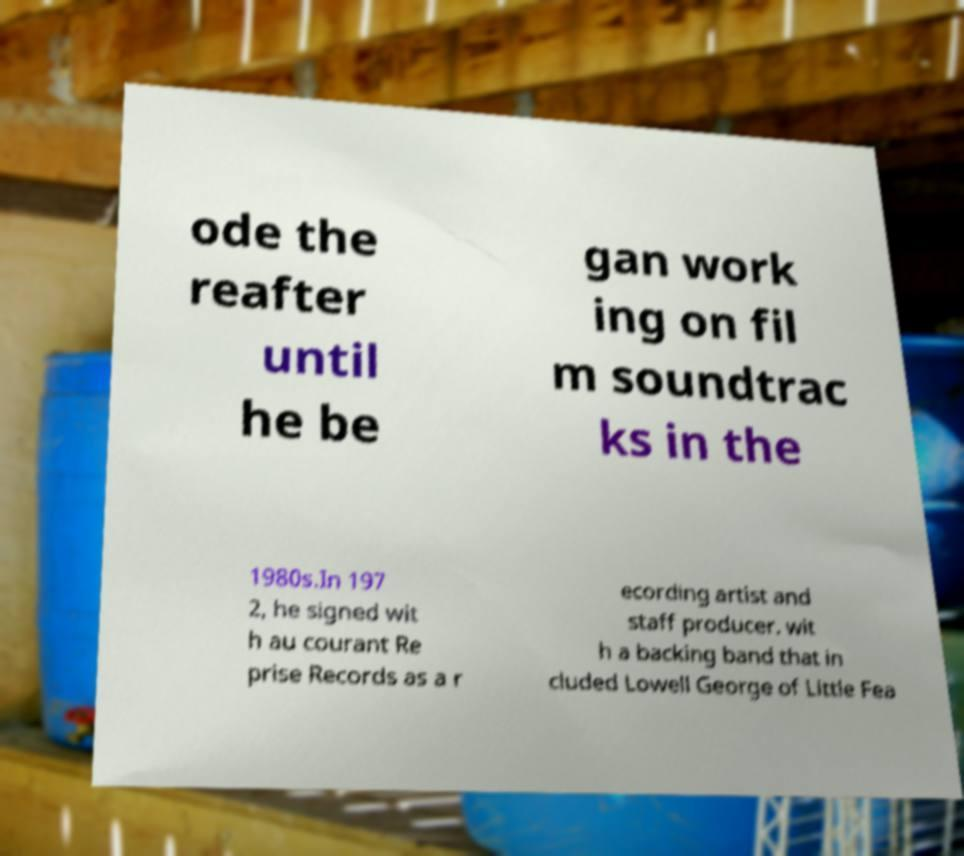Could you assist in decoding the text presented in this image and type it out clearly? ode the reafter until he be gan work ing on fil m soundtrac ks in the 1980s.In 197 2, he signed wit h au courant Re prise Records as a r ecording artist and staff producer. wit h a backing band that in cluded Lowell George of Little Fea 